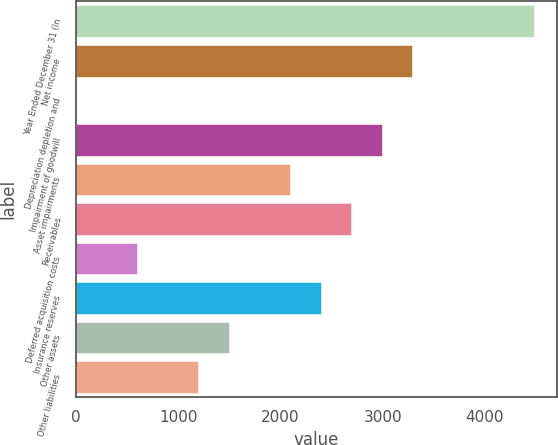<chart> <loc_0><loc_0><loc_500><loc_500><bar_chart><fcel>Year Ended December 31 (In<fcel>Net income<fcel>Depreciation depletion and<fcel>Impairment of goodwill<fcel>Asset impairments<fcel>Receivables<fcel>Deferred acquisition costs<fcel>Insurance reserves<fcel>Other assets<fcel>Other liabilities<nl><fcel>4483.5<fcel>3288.7<fcel>3<fcel>2990<fcel>2093.9<fcel>2691.3<fcel>600.4<fcel>2392.6<fcel>1496.5<fcel>1197.8<nl></chart> 